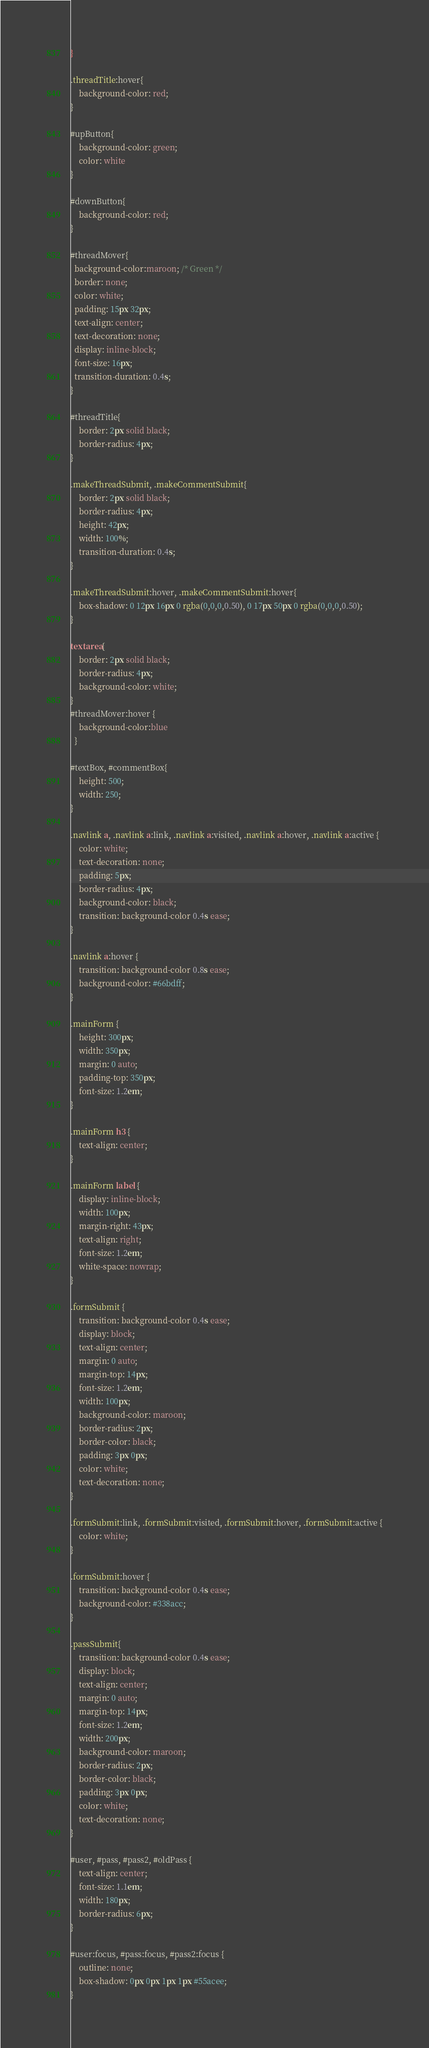<code> <loc_0><loc_0><loc_500><loc_500><_CSS_>}

.threadTitle:hover{
    background-color: red;
}

#upButton{
    background-color: green;
    color: white
}

#downButton{
    background-color: red;
}

#threadMover{
  background-color:maroon; /* Green */
  border: none;
  color: white;
  padding: 15px 32px;
  text-align: center;
  text-decoration: none;
  display: inline-block;
  font-size: 16px;
  transition-duration: 0.4s;
}

#threadTitle{
    border: 2px solid black;
    border-radius: 4px;
}

.makeThreadSubmit, .makeCommentSubmit{
    border: 2px solid black;
    border-radius: 4px;
    height: 42px;
    width: 100%;
    transition-duration: 0.4s;
}

.makeThreadSubmit:hover, .makeCommentSubmit:hover{
    box-shadow: 0 12px 16px 0 rgba(0,0,0,0.50), 0 17px 50px 0 rgba(0,0,0,0.50);
}

textarea{
    border: 2px solid black;
    border-radius: 4px;
    background-color: white;
}
#threadMover:hover {
    background-color:blue
  }

#textBox, #commentBox{
    height: 500;
    width: 250;
}

.navlink a, .navlink a:link, .navlink a:visited, .navlink a:hover, .navlink a:active {
    color: white;
    text-decoration: none;
    padding: 5px;
    border-radius: 4px;
    background-color: black;
    transition: background-color 0.4s ease;
}

.navlink a:hover {
    transition: background-color 0.8s ease;
    background-color: #66bdff;
}

.mainForm {
    height: 300px;
    width: 350px;
    margin: 0 auto;
    padding-top: 350px;
    font-size: 1.2em;
}

.mainForm h3 {
    text-align: center;
}

.mainForm label {
    display: inline-block;
    width: 100px;
    margin-right: 43px;
    text-align: right;
    font-size: 1.2em;
    white-space: nowrap;
}

.formSubmit {
    transition: background-color 0.4s ease;
    display: block;
    text-align: center;
    margin: 0 auto;
    margin-top: 14px;
    font-size: 1.2em;
    width: 100px;
    background-color: maroon;
    border-radius: 2px;
    border-color: black;
    padding: 3px 0px;
    color: white;
    text-decoration: none;
}

.formSubmit:link, .formSubmit:visited, .formSubmit:hover, .formSubmit:active {
    color: white;
}

.formSubmit:hover {
    transition: background-color 0.4s ease;
    background-color: #338acc;
}

.passSubmit{
    transition: background-color 0.4s ease;
    display: block;
    text-align: center;
    margin: 0 auto;
    margin-top: 14px;
    font-size: 1.2em;
    width: 200px;
    background-color: maroon;
    border-radius: 2px;
    border-color: black;
    padding: 3px 0px;
    color: white;
    text-decoration: none;
}

#user, #pass, #pass2, #oldPass {
    text-align: center;
    font-size: 1.1em;
    width: 180px;
    border-radius: 6px;
}

#user:focus, #pass:focus, #pass2:focus {
    outline: none;
    box-shadow: 0px 0px 1px 1px #55acee;
}
</code> 